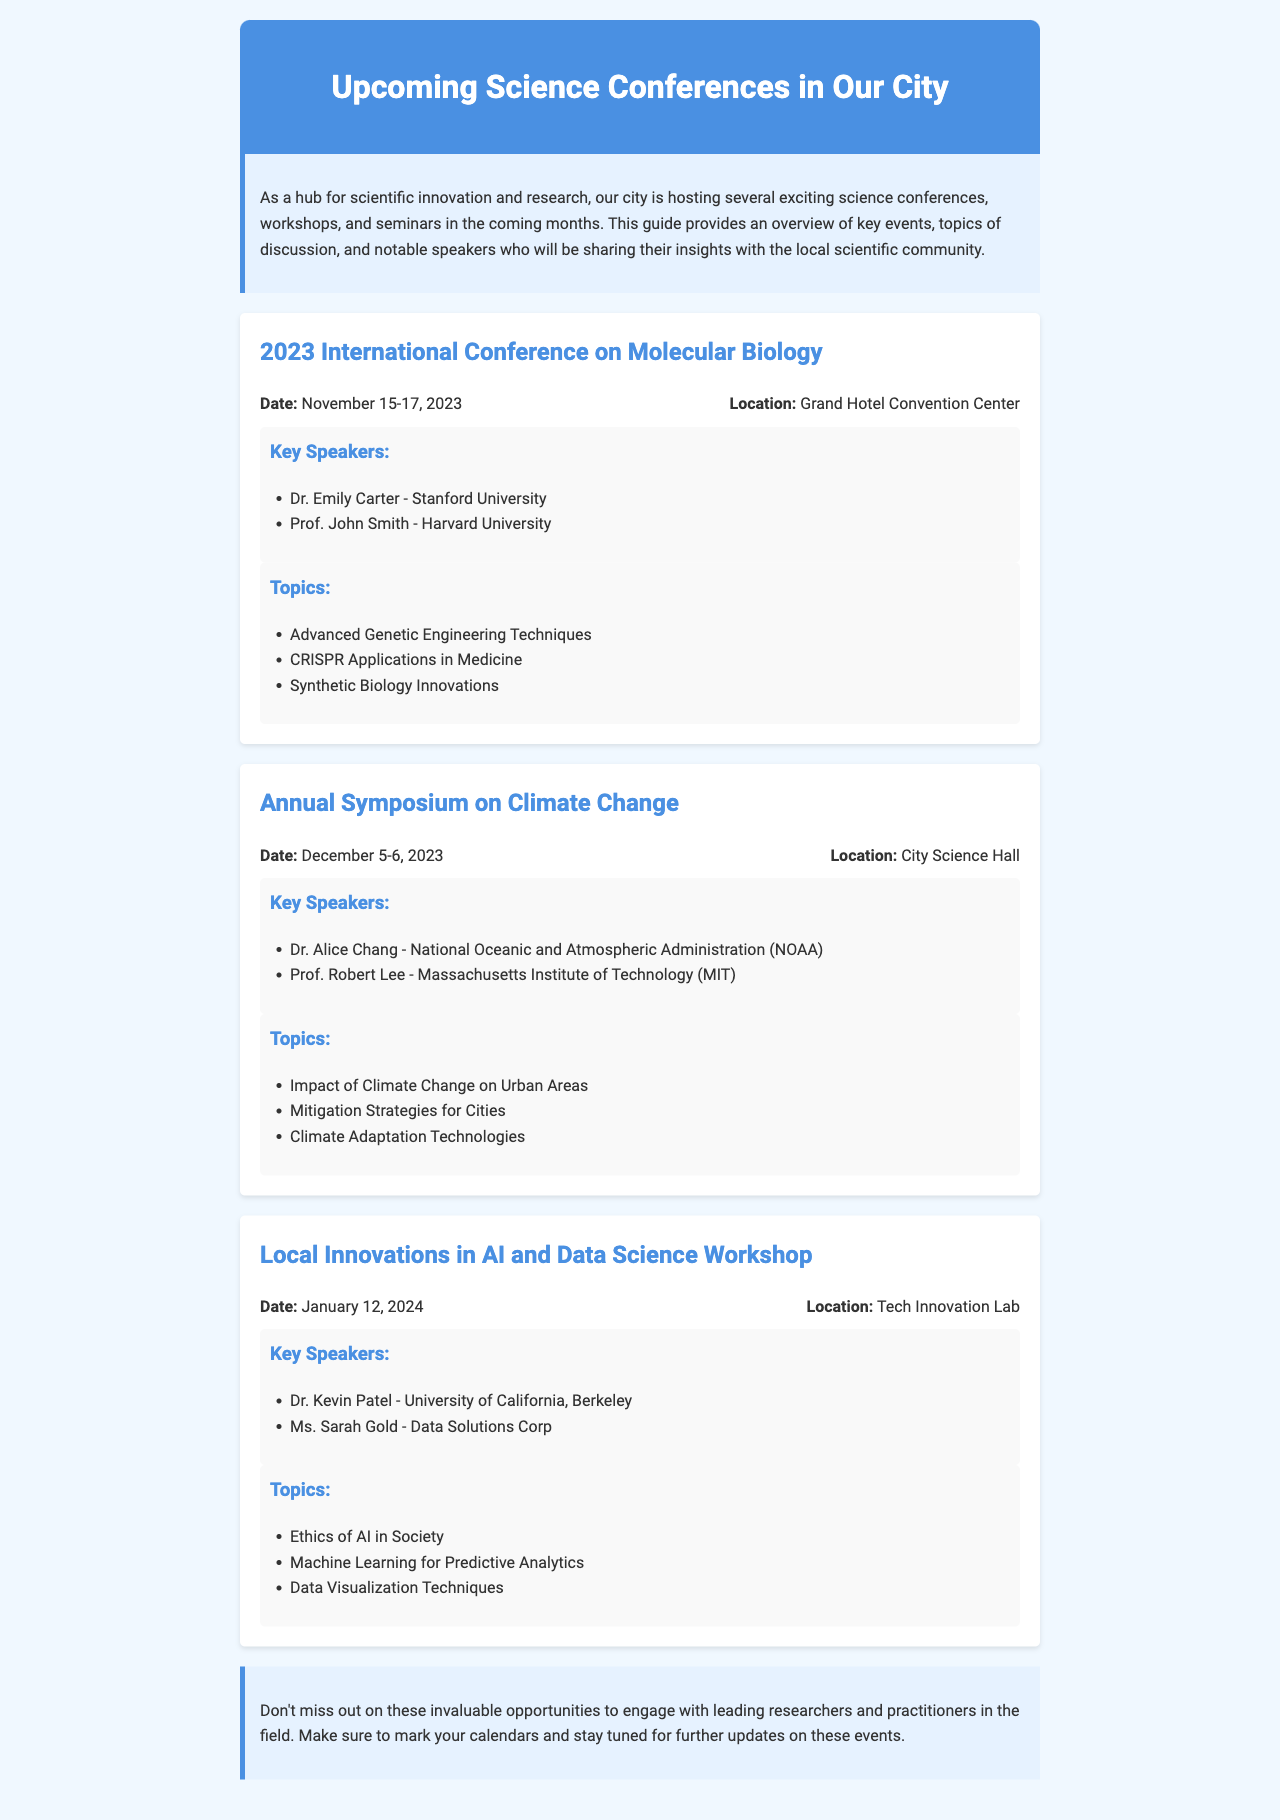What is the date of the International Conference on Molecular Biology? The date is provided in the event section of the document for the International Conference on Molecular Biology.
Answer: November 15-17, 2023 Where will the Annual Symposium on Climate Change take place? The location for the Annual Symposium on Climate Change is stated in the event details section of the document.
Answer: City Science Hall Who is a key speaker at the Local Innovations in AI and Data Science Workshop? The document lists key speakers for the workshop in the respective event section.
Answer: Dr. Kevin Patel How many topics are listed for the Annual Symposium on Climate Change? The number of topics is determined by counting the list provided in the event section of the Annual Symposium on Climate Change.
Answer: Three What is one topic discussed in the International Conference on Molecular Biology? The document provides a list of topics for this event, which includes various scientific discussions.
Answer: CRISPR Applications in Medicine Which university is Dr. Alice Chang affiliated with? The document specifies the affiliation of Dr. Alice Chang under the speakers' section of the Annual Symposium on Climate Change.
Answer: National Oceanic and Atmospheric Administration (NOAA) What is the primary focus of the Local Innovations in AI and Data Science Workshop? The document outlines the topics that will be discussed, focusing on ethics and techniques in AI and data science.
Answer: Ethics of AI in Society 